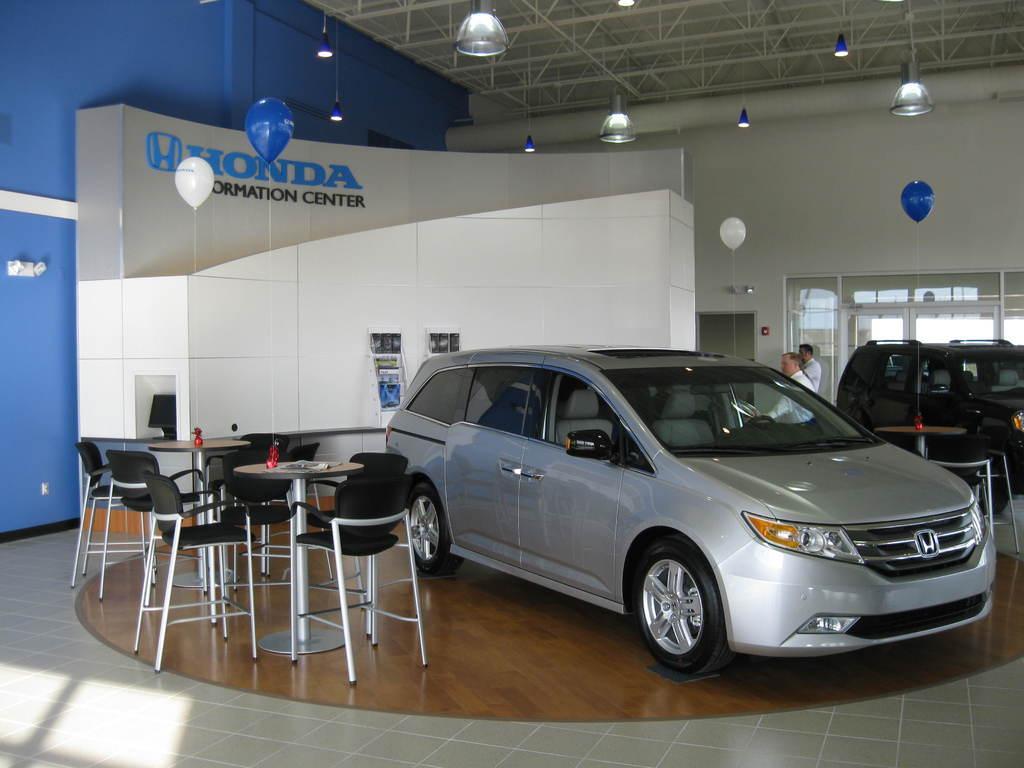How would you summarize this image in a sentence or two? A car in a showroom is shown in the picture. The name of the showroom is "Honda". There are two tables with chairs beside the car. There is a car in black color to the right of the image. 